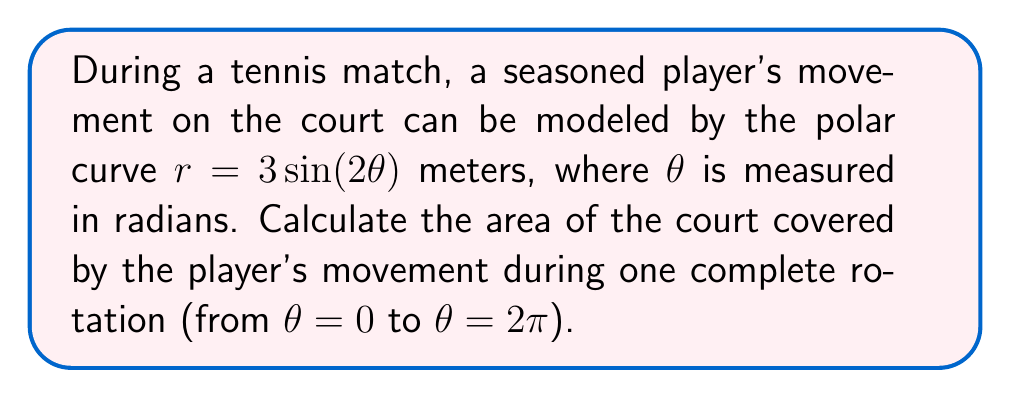Could you help me with this problem? To solve this problem, we'll use polar integration to calculate the area enclosed by the given curve. The formula for the area enclosed by a polar curve is:

$$A = \frac{1}{2}\int_a^b r^2(\theta) d\theta$$

Where $a$ and $b$ are the starting and ending angles, respectively.

Given:
- The polar curve is $r = 3\sin(2\theta)$
- We need to integrate from $\theta = 0$ to $\theta = 2\pi$

Steps:
1) Substitute the given function into the area formula:
   $$A = \frac{1}{2}\int_0^{2\pi} (3\sin(2\theta))^2 d\theta$$

2) Simplify the integrand:
   $$A = \frac{1}{2}\int_0^{2\pi} 9\sin^2(2\theta) d\theta$$

3) Use the trigonometric identity $\sin^2(x) = \frac{1 - \cos(2x)}{2}$:
   $$A = \frac{1}{2}\int_0^{2\pi} 9\left(\frac{1 - \cos(4\theta)}{2}\right) d\theta$$

4) Simplify:
   $$A = \frac{9}{4}\int_0^{2\pi} (1 - \cos(4\theta)) d\theta$$

5) Integrate:
   $$A = \frac{9}{4}\left[\theta - \frac{1}{4}\sin(4\theta)\right]_0^{2\pi}$$

6) Evaluate the definite integral:
   $$A = \frac{9}{4}\left[(2\pi - 0) - (\frac{1}{4}\sin(8\pi) - \frac{1}{4}\sin(0))\right]$$

7) Simplify:
   $$A = \frac{9}{4}(2\pi - 0) = \frac{9\pi}{2}$$

Therefore, the area covered by the player's movement is $\frac{9\pi}{2}$ square meters.
Answer: $\frac{9\pi}{2}$ square meters 